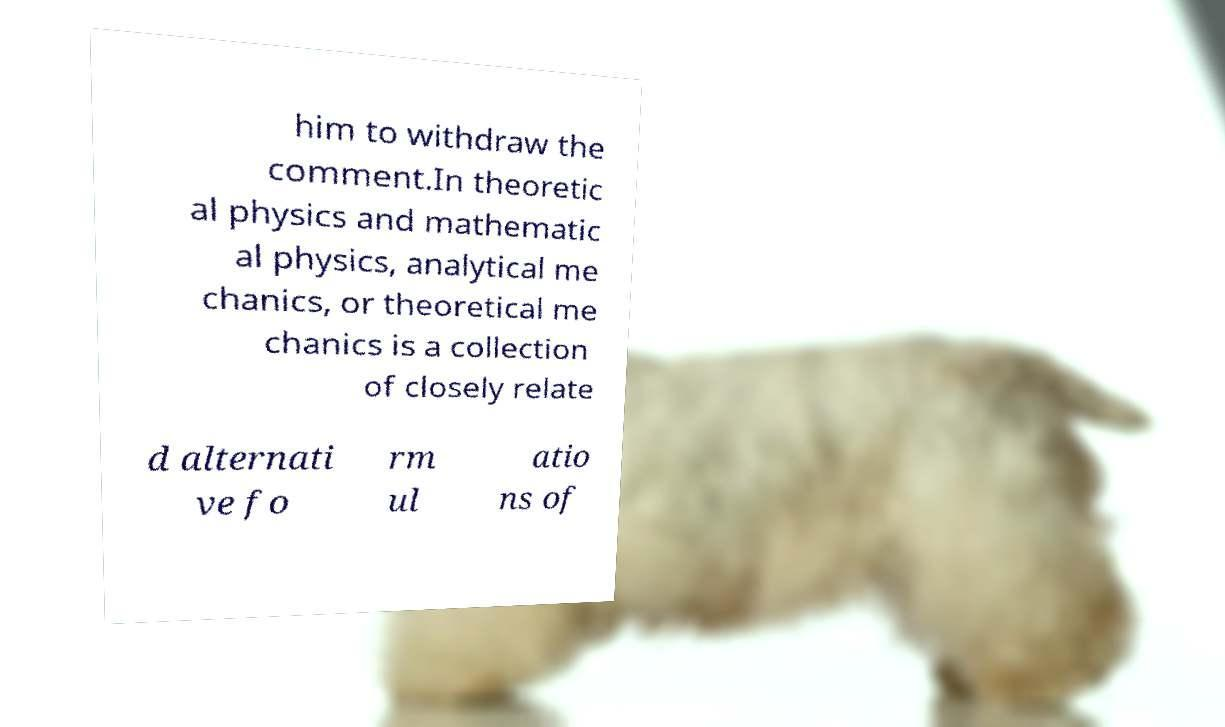Can you read and provide the text displayed in the image?This photo seems to have some interesting text. Can you extract and type it out for me? him to withdraw the comment.In theoretic al physics and mathematic al physics, analytical me chanics, or theoretical me chanics is a collection of closely relate d alternati ve fo rm ul atio ns of 